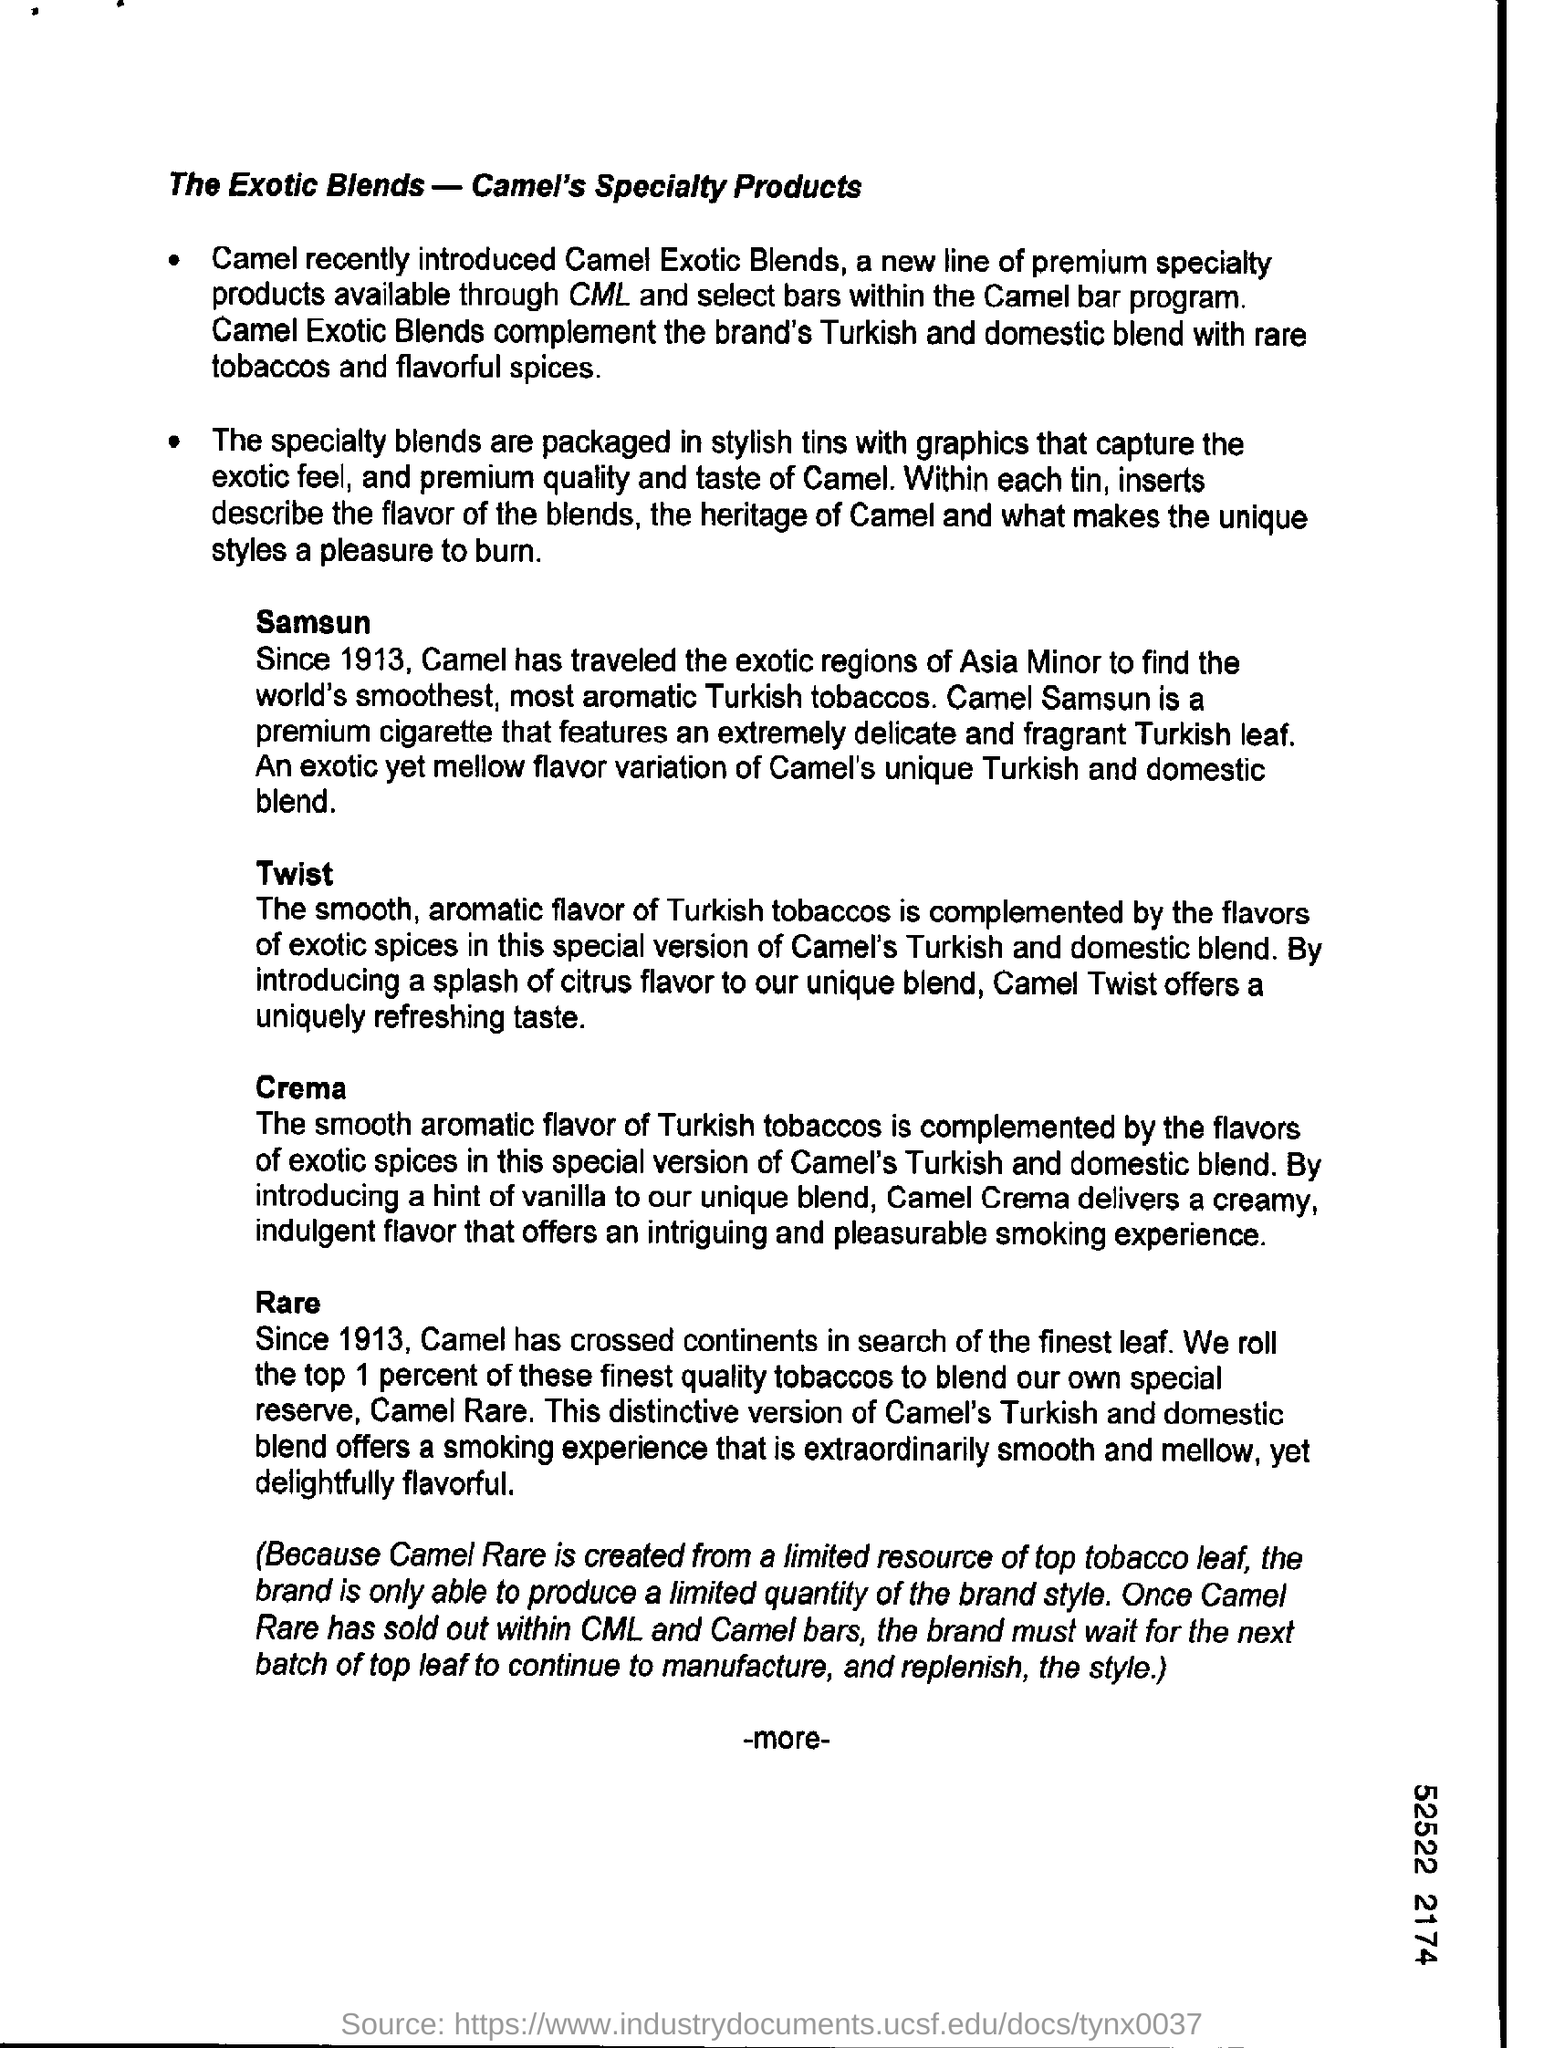Highlight a few significant elements in this photo. Camel Crema delivers a creamy, indulgent flavor that offers an intriguing and pleasurable smoking experience. Camel Exotic Blends complemented a variety of brands with its unique combination of Turkish and Domestic tobaccos, infused with flavorful spices from around the world. Specialty blends are packaged in stylish tins featuring eye-catching graphics. 